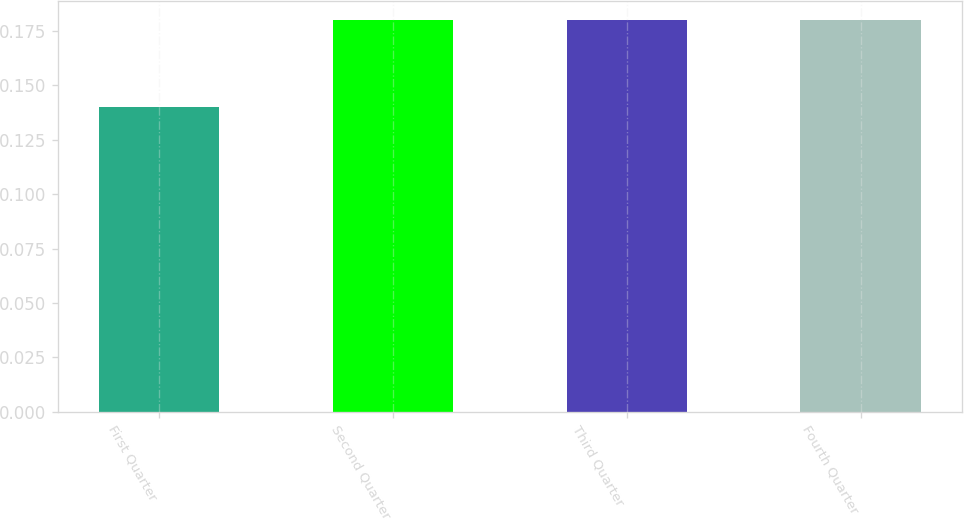Convert chart. <chart><loc_0><loc_0><loc_500><loc_500><bar_chart><fcel>First Quarter<fcel>Second Quarter<fcel>Third Quarter<fcel>Fourth Quarter<nl><fcel>0.14<fcel>0.18<fcel>0.18<fcel>0.18<nl></chart> 